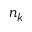<formula> <loc_0><loc_0><loc_500><loc_500>n _ { k }</formula> 